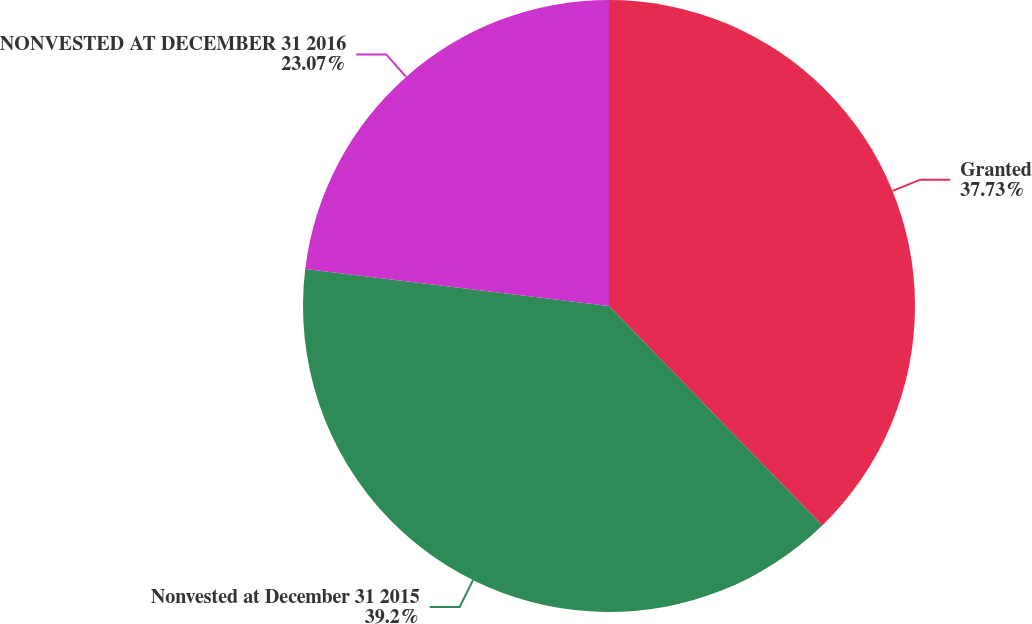Convert chart to OTSL. <chart><loc_0><loc_0><loc_500><loc_500><pie_chart><fcel>Granted<fcel>Nonvested at December 31 2015<fcel>NONVESTED AT DECEMBER 31 2016<nl><fcel>37.73%<fcel>39.2%<fcel>23.07%<nl></chart> 